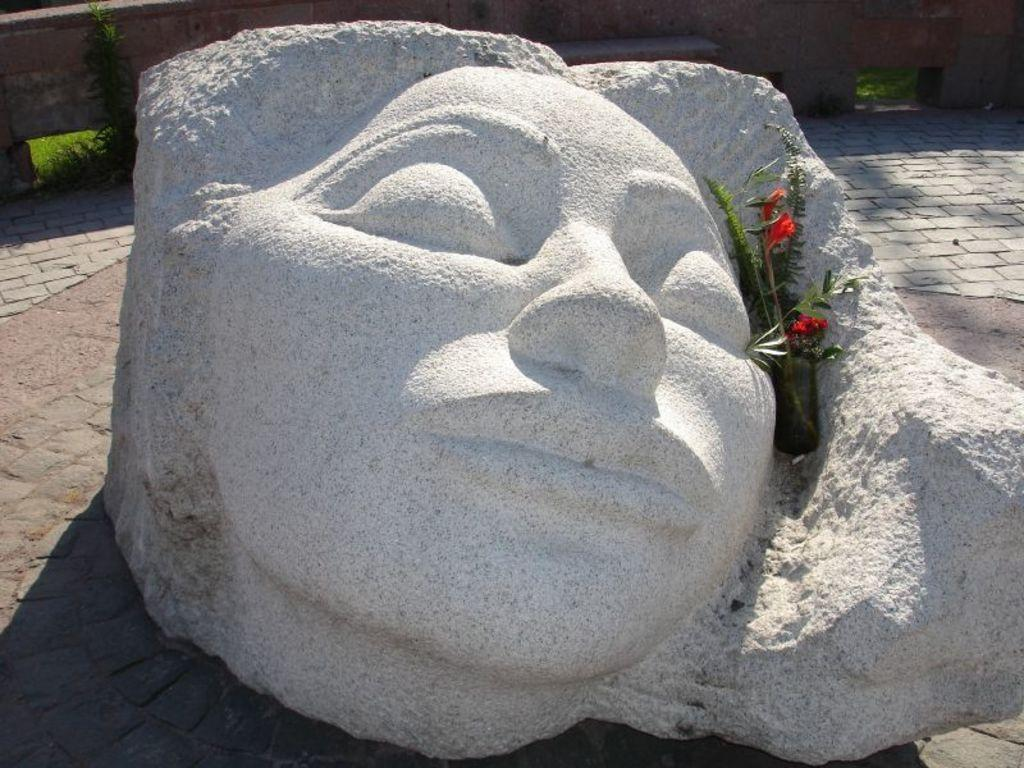What is located in the foreground of the image? There is a sculpture, flowers, and a plant in the foreground of the image. What can be seen in the background of the image? There is a wall, grass, and plants in the background of the image. What type of pathway is visible at the bottom of the image? There is a walkway at the bottom of the image. Can you hear someone coughing in the image? There is no auditory information provided in the image, so it is impossible to determine if someone is coughing. Is there a gun visible in the image? There is no mention of a gun in the provided facts, and therefore no such object is present in the image. 